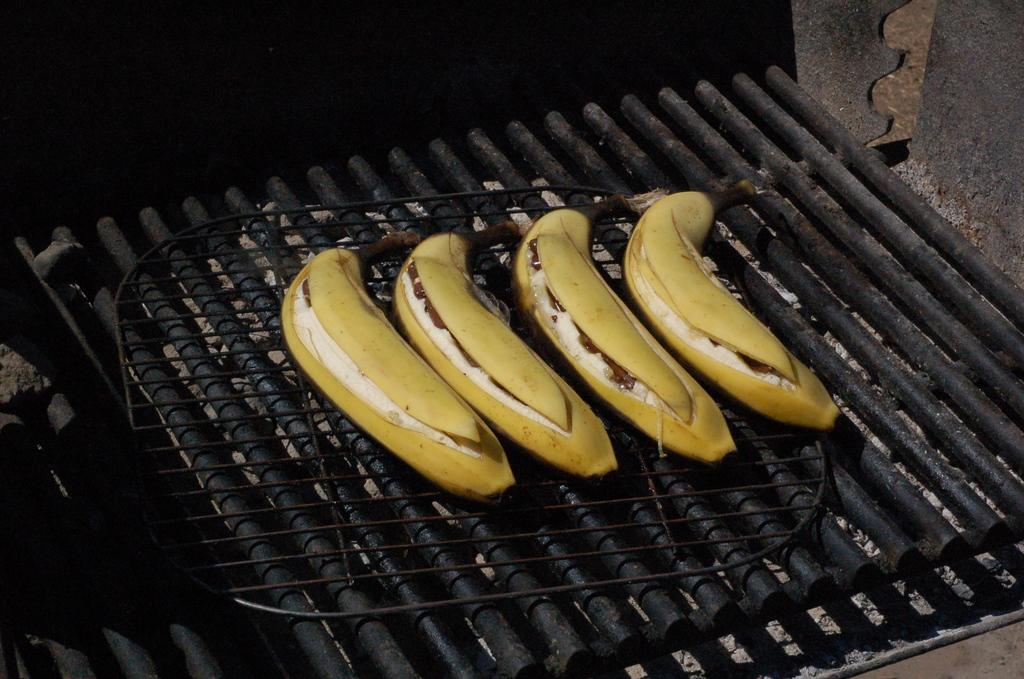What is being cooked on the grill stove in the image? There are bananas on the grill stove in the image. What can be seen in the background of the image? There is a black background in the image. What type of cushion is being used by the frog in the image? There is no frog or cushion present in the image. 